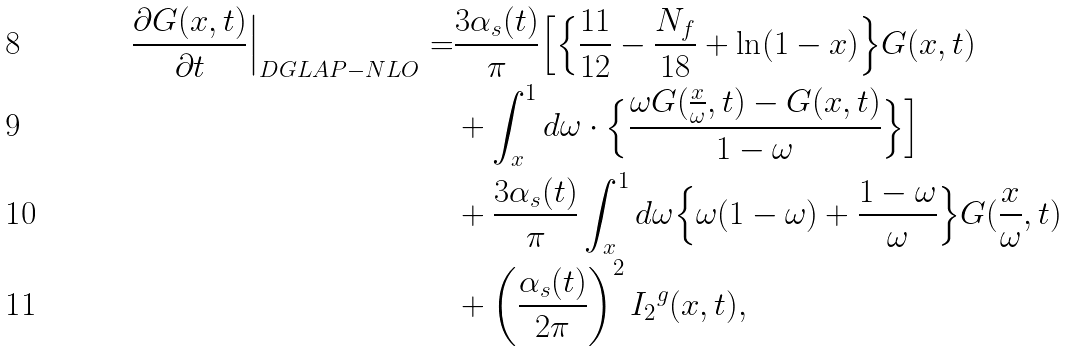Convert formula to latex. <formula><loc_0><loc_0><loc_500><loc_500>\frac { \partial G ( x , t ) } { \partial t } \Big | _ { D G L A P - N L O } = & \frac { 3 \alpha _ { s } ( t ) } { \pi } \Big [ \Big \{ \frac { 1 1 } { 1 2 } - \frac { N _ { f } } { 1 8 } + \ln ( 1 - x ) \Big \} G ( x , t ) \\ & + \int _ { x } ^ { 1 } d \omega \cdot \Big \{ \frac { \omega G ( \frac { x } { \omega } , t ) - G ( x , t ) } { 1 - \omega } \Big \} \Big ] \\ & + \frac { 3 \alpha _ { s } ( t ) } { \pi } \int _ { x } ^ { 1 } d \omega \Big \{ \omega ( 1 - \omega ) + \frac { 1 - \omega } { \omega } \Big \} G ( \frac { x } { \omega } , t ) \\ & + \left ( \frac { \alpha _ { s } ( t ) } { 2 \pi } \right ) ^ { 2 } { I _ { 2 } } ^ { g } ( x , t ) ,</formula> 